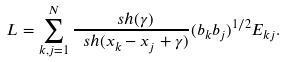<formula> <loc_0><loc_0><loc_500><loc_500>L = \sum _ { k , j = 1 } ^ { N } \frac { \ s h ( \gamma ) } { \ s h ( x _ { k } - x _ { j } + \gamma ) } ( b _ { k } b _ { j } ) ^ { 1 / 2 } E _ { k j } .</formula> 